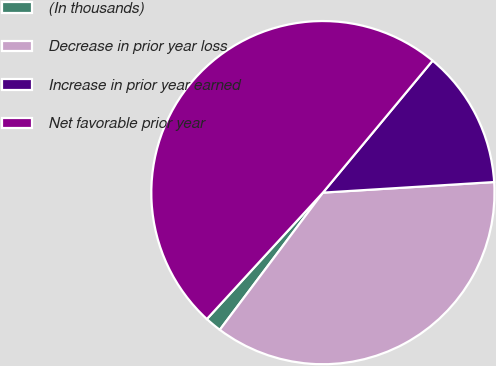Convert chart. <chart><loc_0><loc_0><loc_500><loc_500><pie_chart><fcel>(In thousands)<fcel>Decrease in prior year loss<fcel>Increase in prior year earned<fcel>Net favorable prior year<nl><fcel>1.56%<fcel>36.24%<fcel>12.98%<fcel>49.22%<nl></chart> 